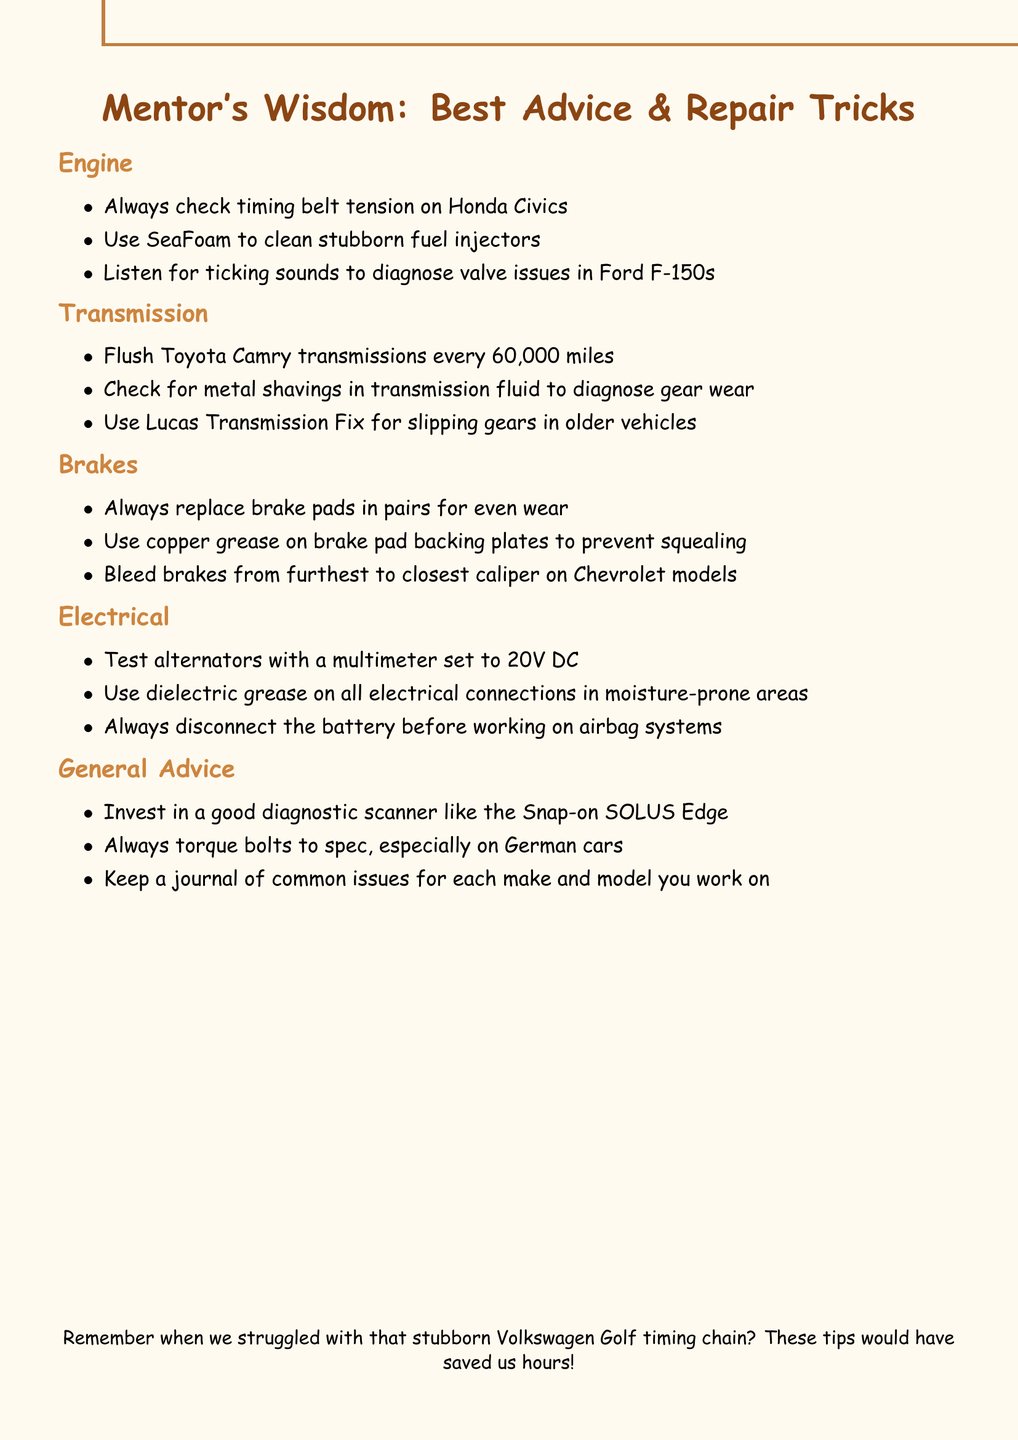What is the first tip under the Engine section? The Engine section lists several tips, with the first being "Always check timing belt tension on Honda Civics."
Answer: Always check timing belt tension on Honda Civics How often should Toyota Camry transmissions be flushed? The document specifies that Toyota Camry transmissions should be flushed every 60,000 miles.
Answer: Every 60,000 miles What should you use on brake pad backing plates to prevent squealing? The document states that copper grease should be used on brake pad backing plates to prevent squealing.
Answer: Copper grease What is the multimeter setting for testing alternators? The document indicates that alternators should be tested with a multimeter set to 20V DC.
Answer: 20V DC Which system requires the battery to be disconnected before working on airbags? The Electrical section emphasizes that the battery should always be disconnected before working on airbag systems.
Answer: Airbag systems Which brand of diagnostic scanner does the mentor recommend? According to the General Advice section, the mentor recommends investing in a diagnostic scanner like the Snap-on SOLUS Edge.
Answer: Snap-on SOLUS Edge What is the last tip mentioned in the document? The last tip in the document suggests keeping a journal of common issues for each make and model worked on.
Answer: Keep a journal of common issues for each make and model you work on Which vehicle model is specifically mentioned in relation to bleeding brakes? The document mentions that brakes should be bled from furthest to closest caliper on Chevrolet models.
Answer: Chevrolet models 